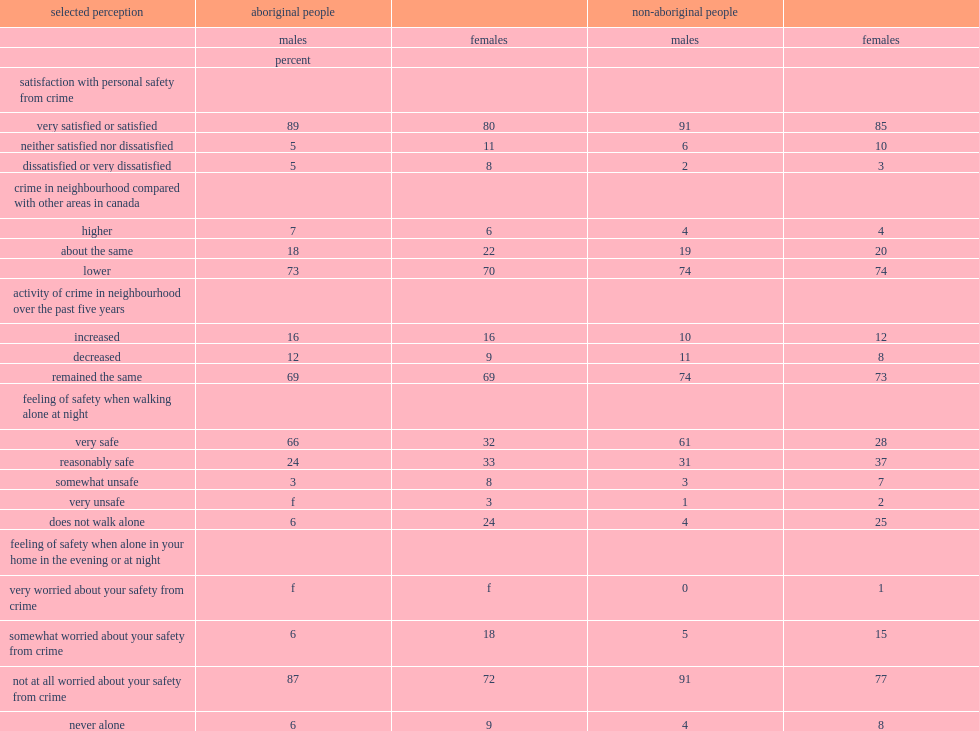What was the percent of aboriginal females were likely to report being satisfied or very satisfied with their personal safety from crime? 80.0. What was the percent of aboriginal males were likely to report being satisfied or very satisfied with their personal safety from crime? 89.0. 